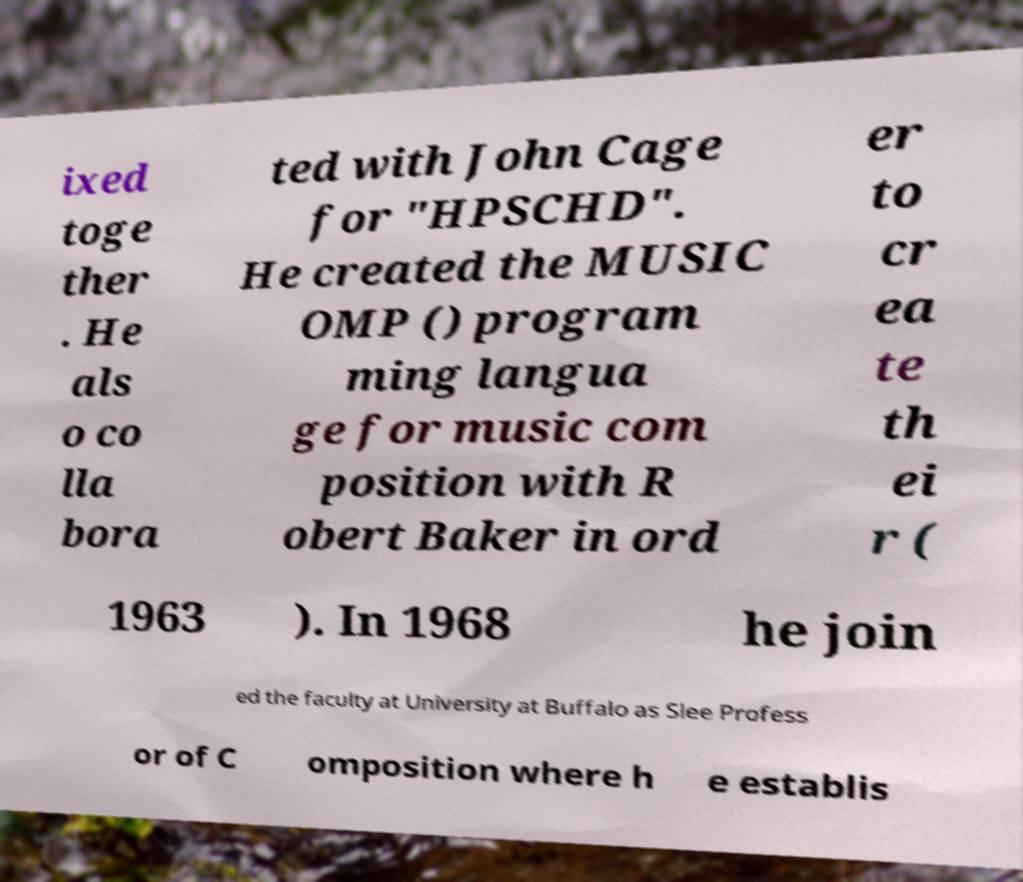Can you accurately transcribe the text from the provided image for me? ixed toge ther . He als o co lla bora ted with John Cage for "HPSCHD". He created the MUSIC OMP () program ming langua ge for music com position with R obert Baker in ord er to cr ea te th ei r ( 1963 ). In 1968 he join ed the faculty at University at Buffalo as Slee Profess or of C omposition where h e establis 